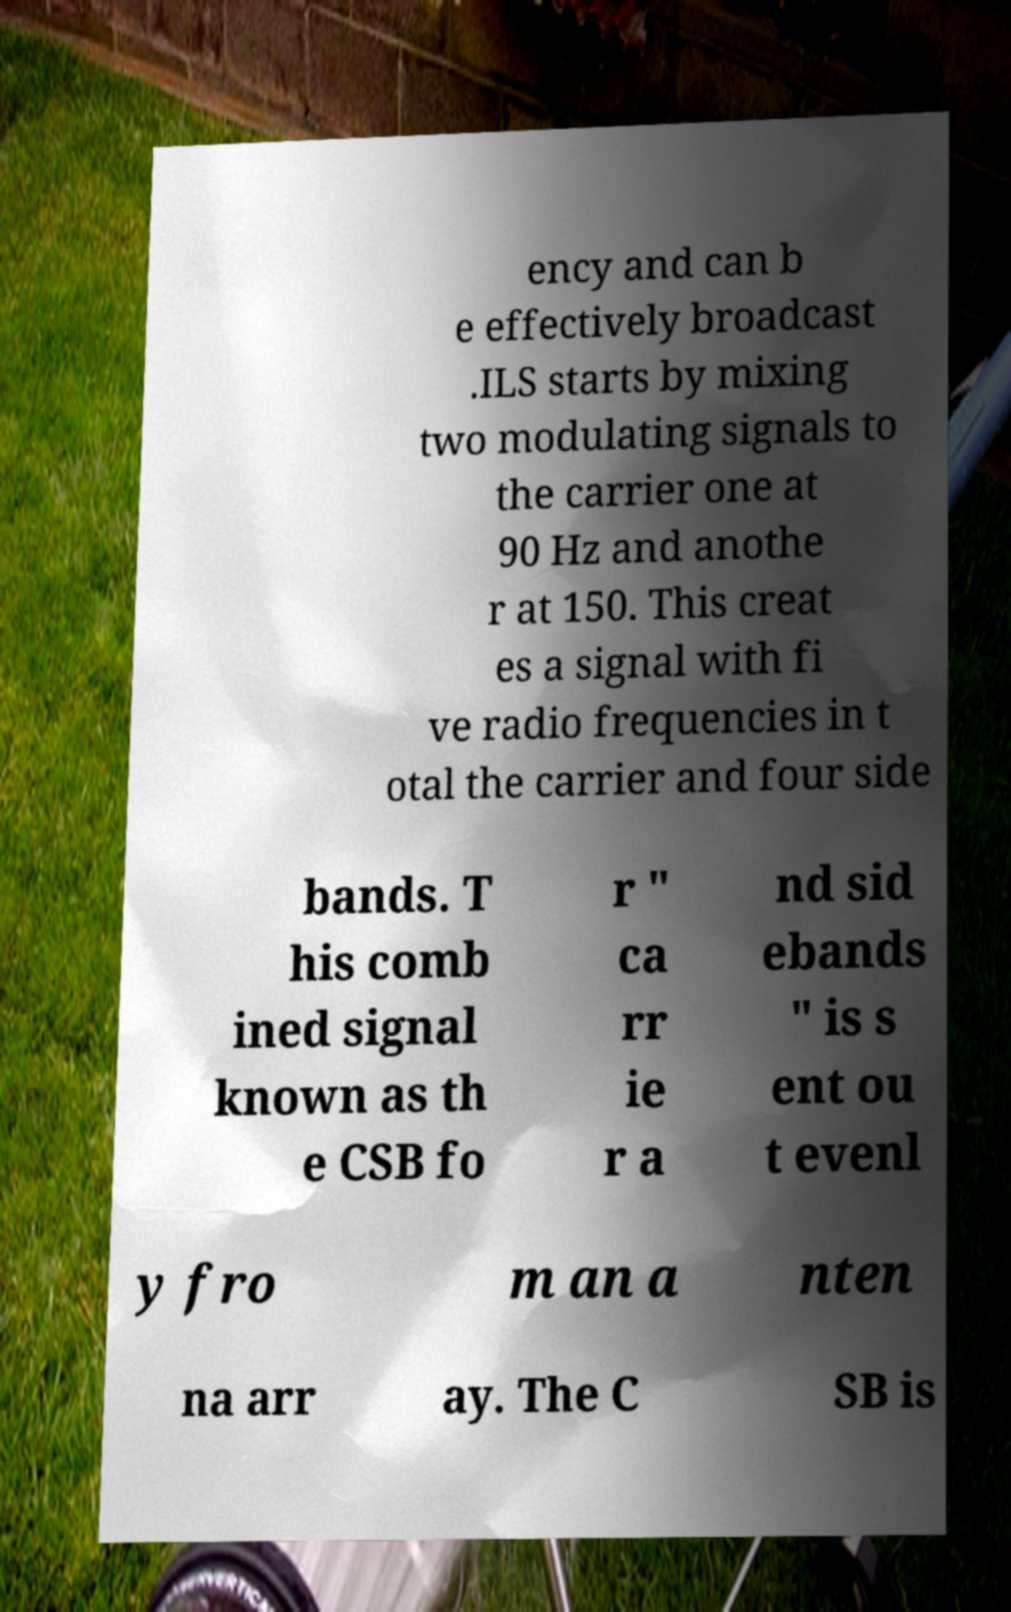Please identify and transcribe the text found in this image. ency and can b e effectively broadcast .ILS starts by mixing two modulating signals to the carrier one at 90 Hz and anothe r at 150. This creat es a signal with fi ve radio frequencies in t otal the carrier and four side bands. T his comb ined signal known as th e CSB fo r " ca rr ie r a nd sid ebands " is s ent ou t evenl y fro m an a nten na arr ay. The C SB is 